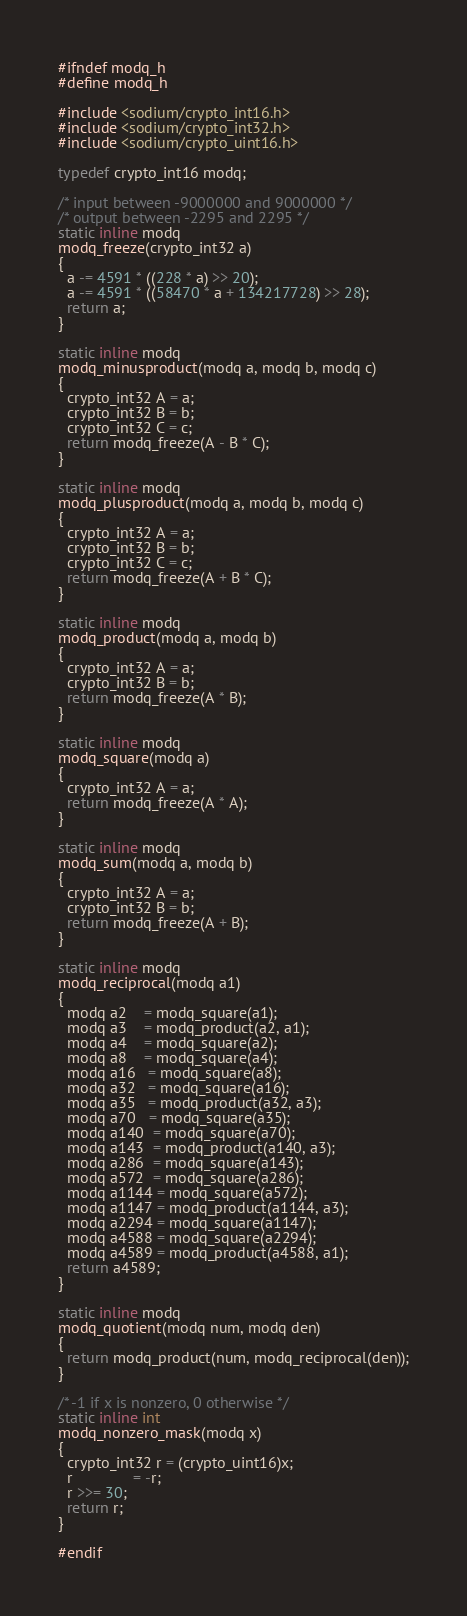Convert code to text. <code><loc_0><loc_0><loc_500><loc_500><_C_>#ifndef modq_h
#define modq_h

#include <sodium/crypto_int16.h>
#include <sodium/crypto_int32.h>
#include <sodium/crypto_uint16.h>

typedef crypto_int16 modq;

/* input between -9000000 and 9000000 */
/* output between -2295 and 2295 */
static inline modq
modq_freeze(crypto_int32 a)
{
  a -= 4591 * ((228 * a) >> 20);
  a -= 4591 * ((58470 * a + 134217728) >> 28);
  return a;
}

static inline modq
modq_minusproduct(modq a, modq b, modq c)
{
  crypto_int32 A = a;
  crypto_int32 B = b;
  crypto_int32 C = c;
  return modq_freeze(A - B * C);
}

static inline modq
modq_plusproduct(modq a, modq b, modq c)
{
  crypto_int32 A = a;
  crypto_int32 B = b;
  crypto_int32 C = c;
  return modq_freeze(A + B * C);
}

static inline modq
modq_product(modq a, modq b)
{
  crypto_int32 A = a;
  crypto_int32 B = b;
  return modq_freeze(A * B);
}

static inline modq
modq_square(modq a)
{
  crypto_int32 A = a;
  return modq_freeze(A * A);
}

static inline modq
modq_sum(modq a, modq b)
{
  crypto_int32 A = a;
  crypto_int32 B = b;
  return modq_freeze(A + B);
}

static inline modq
modq_reciprocal(modq a1)
{
  modq a2    = modq_square(a1);
  modq a3    = modq_product(a2, a1);
  modq a4    = modq_square(a2);
  modq a8    = modq_square(a4);
  modq a16   = modq_square(a8);
  modq a32   = modq_square(a16);
  modq a35   = modq_product(a32, a3);
  modq a70   = modq_square(a35);
  modq a140  = modq_square(a70);
  modq a143  = modq_product(a140, a3);
  modq a286  = modq_square(a143);
  modq a572  = modq_square(a286);
  modq a1144 = modq_square(a572);
  modq a1147 = modq_product(a1144, a3);
  modq a2294 = modq_square(a1147);
  modq a4588 = modq_square(a2294);
  modq a4589 = modq_product(a4588, a1);
  return a4589;
}

static inline modq
modq_quotient(modq num, modq den)
{
  return modq_product(num, modq_reciprocal(den));
}

/* -1 if x is nonzero, 0 otherwise */
static inline int
modq_nonzero_mask(modq x)
{
  crypto_int32 r = (crypto_uint16)x;
  r              = -r;
  r >>= 30;
  return r;
}

#endif
</code> 